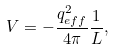<formula> <loc_0><loc_0><loc_500><loc_500>V = - \frac { { q _ { e f f } ^ { 2 } } } { 4 \pi } \frac { 1 } { L } ,</formula> 